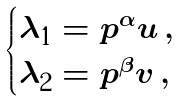<formula> <loc_0><loc_0><loc_500><loc_500>\begin{cases} \lambda _ { 1 } = p ^ { \alpha } u \, , \\ \lambda _ { 2 } = p ^ { \beta } v \, , \end{cases}</formula> 